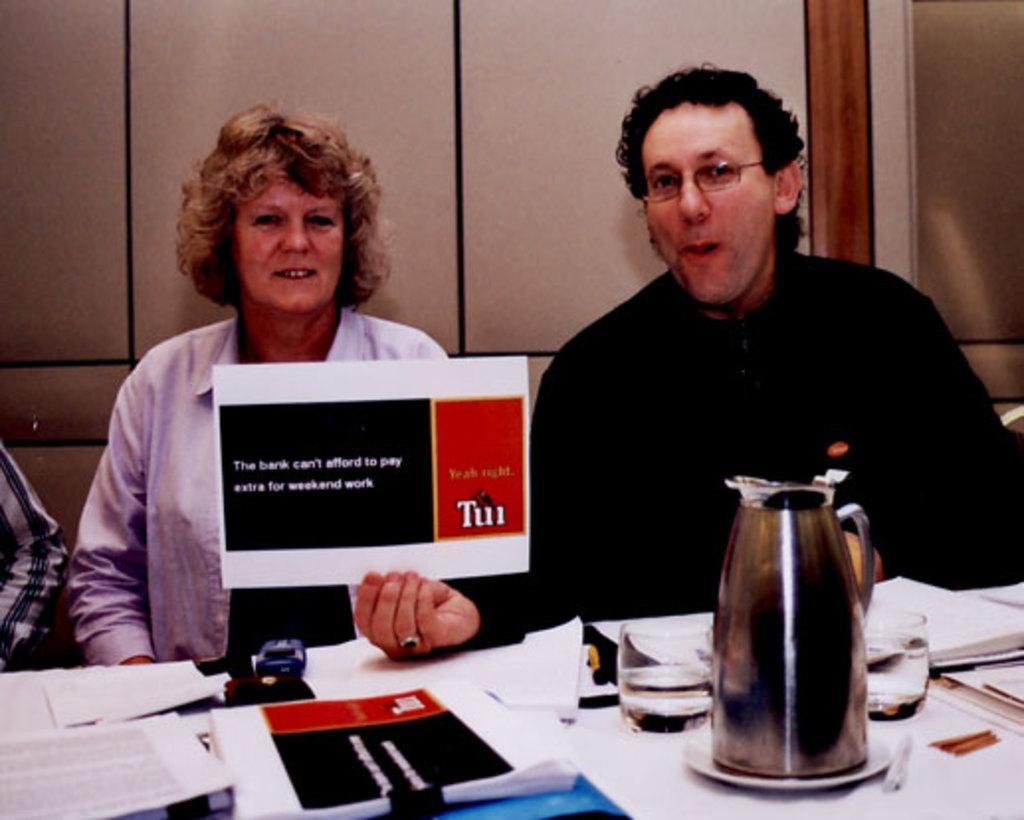How would you summarize this image in a sentence or two? In this image In the middle there is a table on that there are many papers, glass and jar. In the right there is a man he wear black t shirt he is holding a poster. On the left there is a woman her hair is short she wears shirt. 